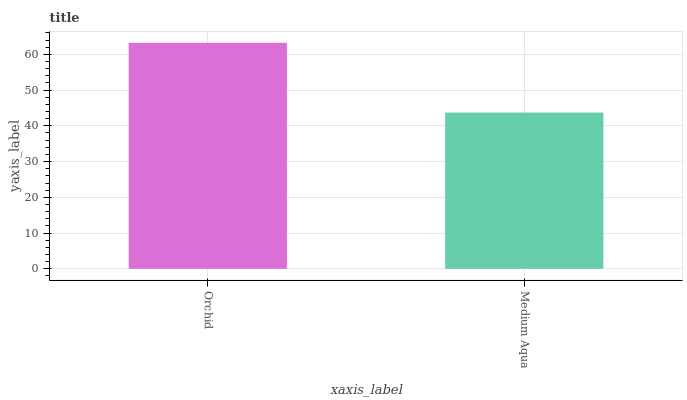Is Medium Aqua the minimum?
Answer yes or no. Yes. Is Orchid the maximum?
Answer yes or no. Yes. Is Medium Aqua the maximum?
Answer yes or no. No. Is Orchid greater than Medium Aqua?
Answer yes or no. Yes. Is Medium Aqua less than Orchid?
Answer yes or no. Yes. Is Medium Aqua greater than Orchid?
Answer yes or no. No. Is Orchid less than Medium Aqua?
Answer yes or no. No. Is Orchid the high median?
Answer yes or no. Yes. Is Medium Aqua the low median?
Answer yes or no. Yes. Is Medium Aqua the high median?
Answer yes or no. No. Is Orchid the low median?
Answer yes or no. No. 